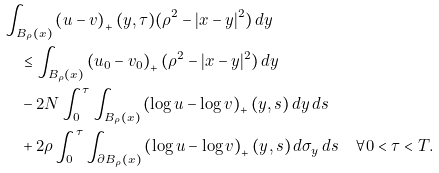Convert formula to latex. <formula><loc_0><loc_0><loc_500><loc_500>& \int _ { B _ { \rho } ( x ) } \left ( u - v \right ) _ { + } ( y , \tau ) ( \rho ^ { 2 } - | x - y | ^ { 2 } ) \, d y \\ & \quad \leq \int _ { B _ { \rho } ( x ) } \left ( u _ { 0 } - v _ { 0 } \right ) _ { + } ( \rho ^ { 2 } - | x - y | ^ { 2 } ) \, d y \\ & \quad - 2 N \int _ { 0 } ^ { \tau } \int _ { B _ { \rho } ( x ) } \left ( \log u - \log v \right ) _ { + } ( y , s ) \, d y \, d s \\ & \quad + 2 \rho \int _ { 0 } ^ { \tau } \int _ { \partial B _ { \rho } ( x ) } \left ( \log u - \log v \right ) _ { + } ( y , s ) \, d \sigma _ { y } \, d s \quad \forall 0 < \tau < T .</formula> 